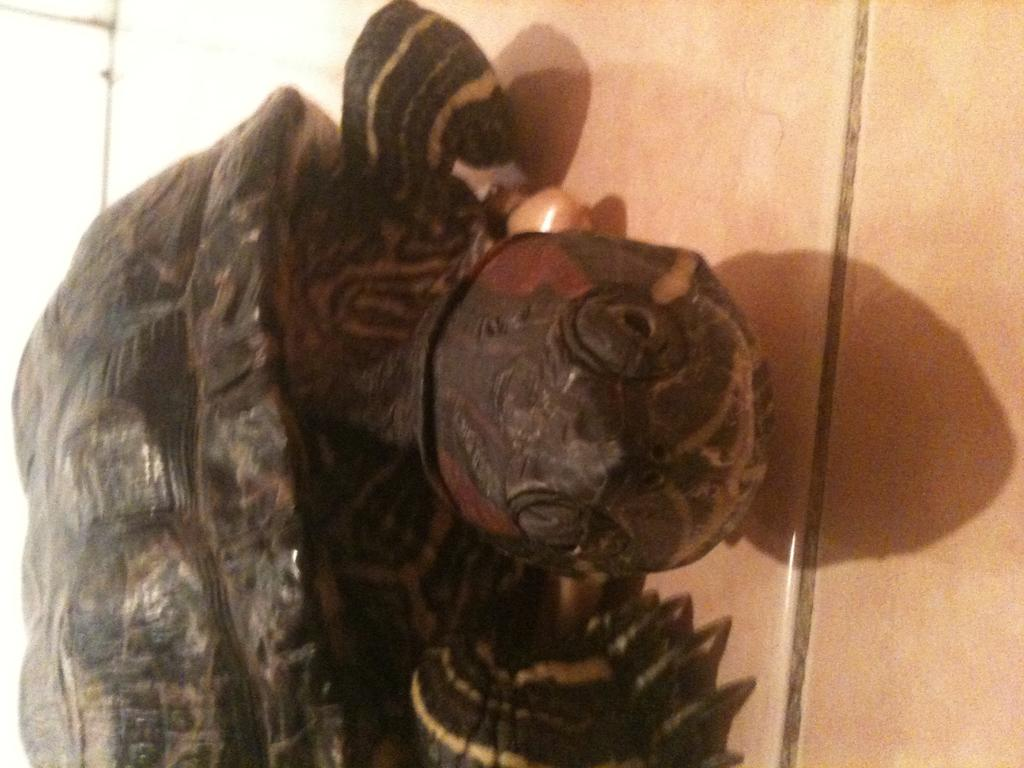What type of animal is in the image? There is a turtle in the image. Where is the turtle located in the image? The turtle is on the floor. What type of organization is the turtle a part of in the image? There is no organization present in the image, and the turtle is not a part of any organization. 